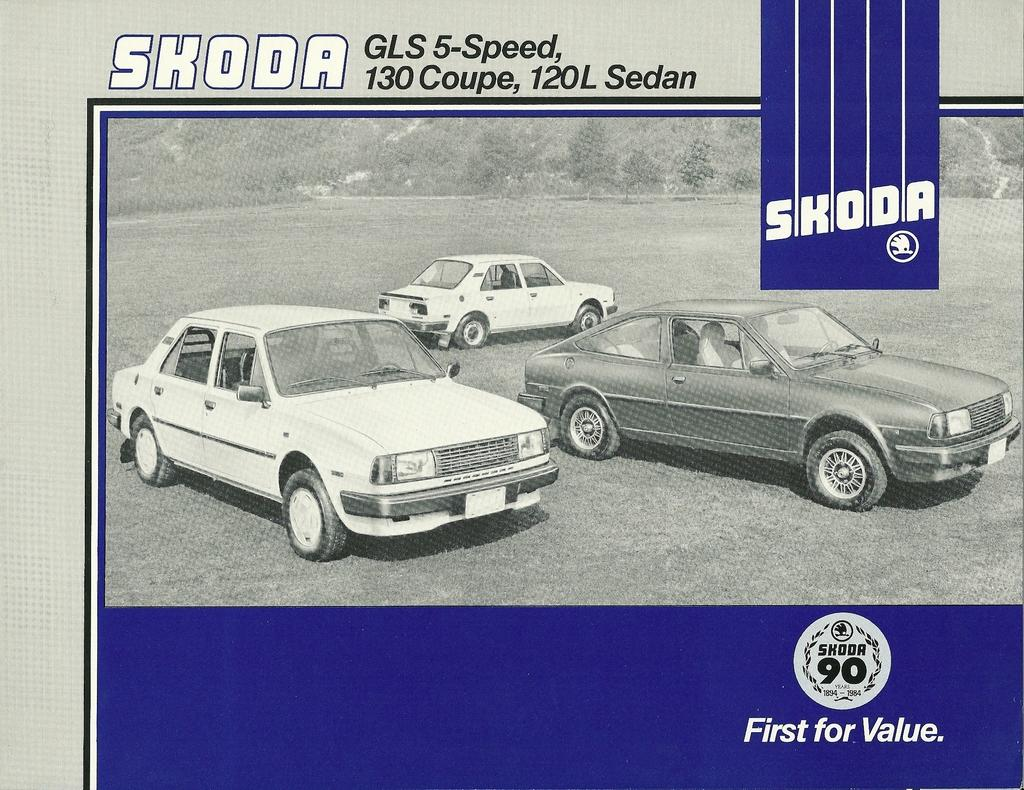What is the main object in the image? There is a pamphlet in thet in the image. What can be seen on the surface of the pamphlet? The pamphlet has three car images on its surface. Which brand are the car images associated with? The car images are associated with SKODA. Can you see a baby holding a match in the image? There is no baby or match present in the image; it only features a pamphlet with car images. 